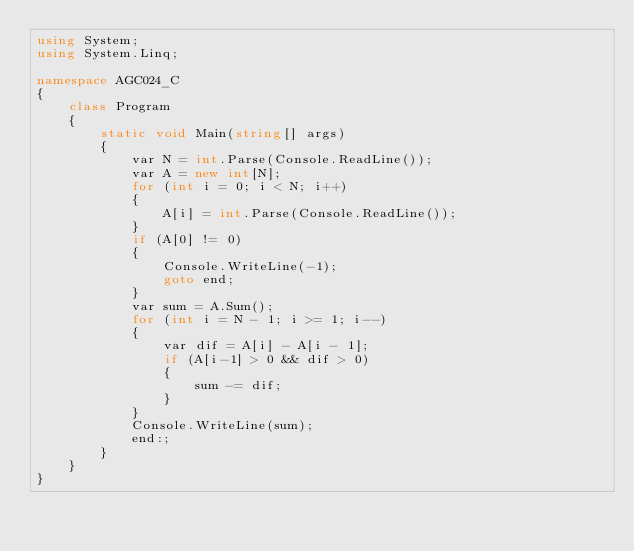Convert code to text. <code><loc_0><loc_0><loc_500><loc_500><_C#_>using System;
using System.Linq;

namespace AGC024_C
{
    class Program
    {
        static void Main(string[] args)
        {
            var N = int.Parse(Console.ReadLine());
            var A = new int[N];
            for (int i = 0; i < N; i++)
            {
                A[i] = int.Parse(Console.ReadLine());
            }
            if (A[0] != 0)
            {
                Console.WriteLine(-1);
                goto end;
            }
            var sum = A.Sum();
            for (int i = N - 1; i >= 1; i--)
            {
                var dif = A[i] - A[i - 1];
                if (A[i-1] > 0 && dif > 0)
                {
                    sum -= dif;
                }
            }
            Console.WriteLine(sum);
            end:;
        }
    }
}
</code> 